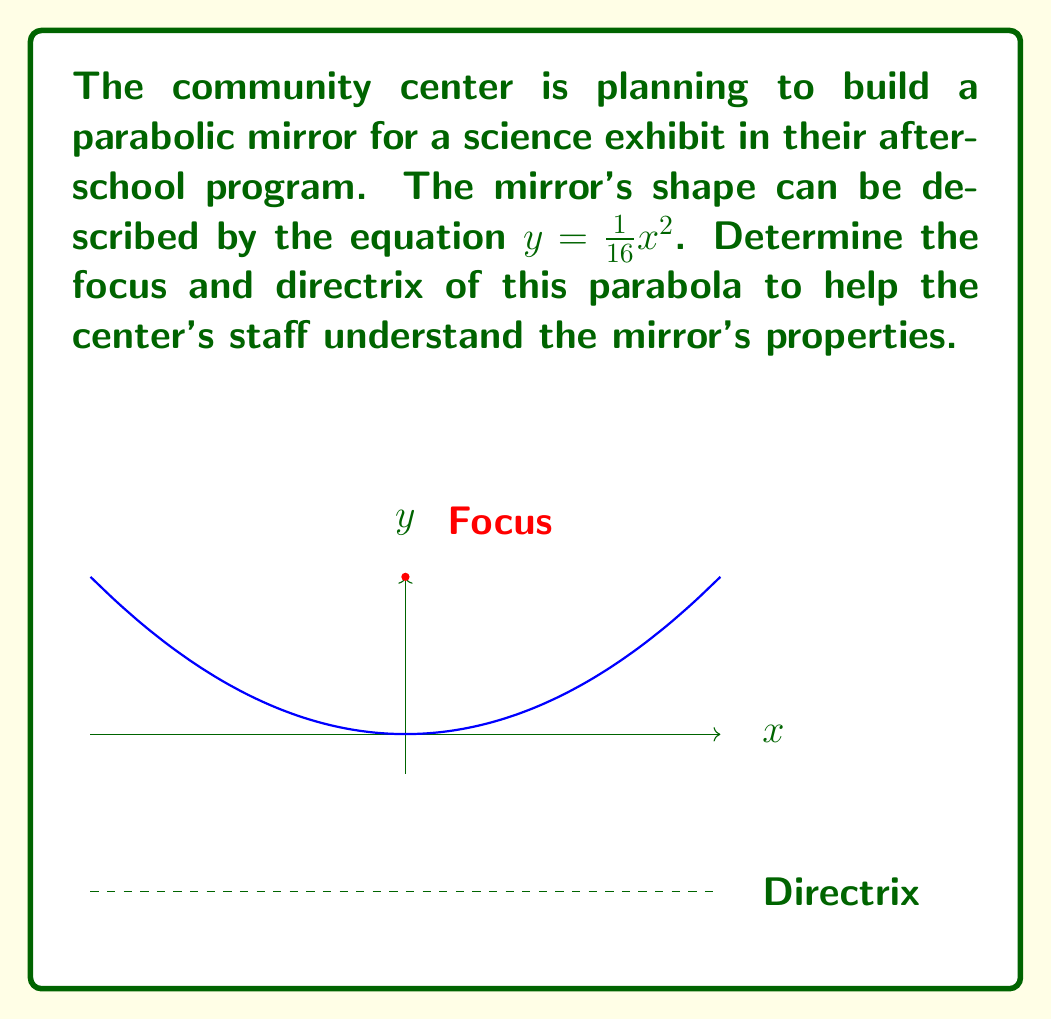Show me your answer to this math problem. Let's approach this step-by-step:

1) The general form of a parabola with a vertical axis of symmetry is:
   $y = a(x-h)^2 + k$
   where $(h,k)$ is the vertex and $a$ determines the direction and width.

2) Our equation is $y = \frac{1}{16}x^2$, which means:
   $a = \frac{1}{16}$
   $h = 0$ (no horizontal shift)
   $k = 0$ (no vertical shift)

3) For a parabola opening upward (which ours does since $a > 0$), the focus is located $\frac{1}{4a}$ units above the vertex.
   Distance to focus = $\frac{1}{4a} = \frac{1}{4(\frac{1}{16})} = 4$

4) Therefore, the focus is at $(0, 4)$.

5) The directrix is located the same distance below the vertex as the focus is above it.
   So, the directrix is the horizontal line $y = -4$.

6) We can express the directrix as an equation: $y = -4$
Answer: Focus: $(0, 4)$; Directrix: $y = -4$ 